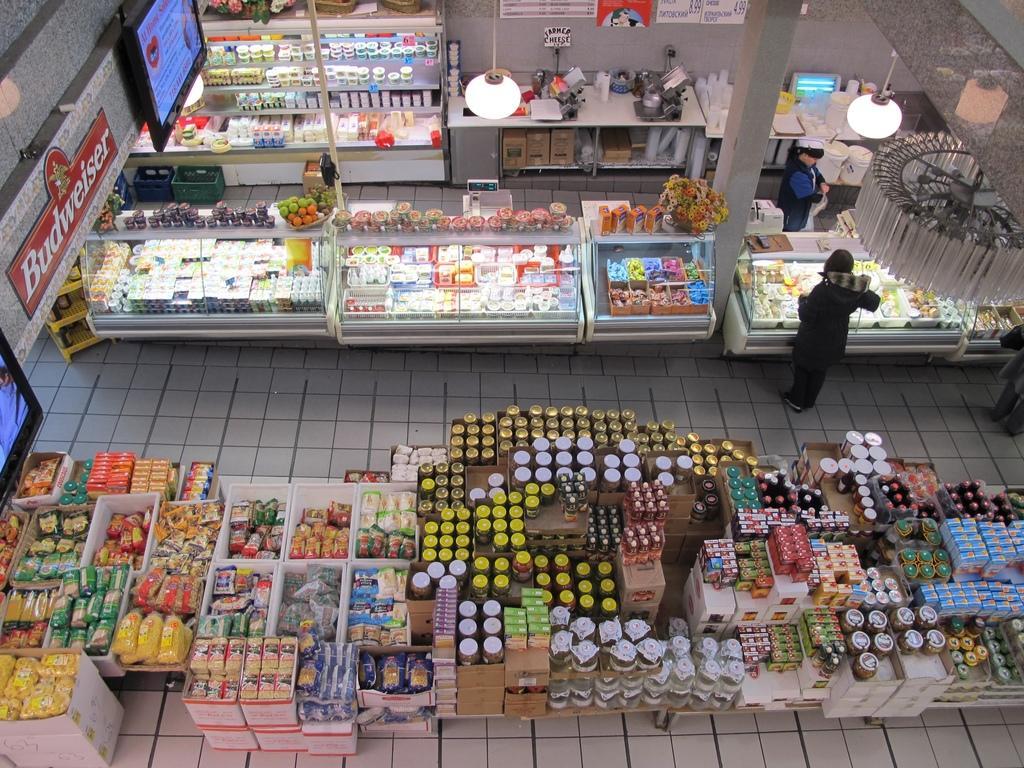Describe this image in one or two sentences. In the image we can see there are many people standing and wearing clothes. Here we can see the store, food items and lights. Here we can see the floor, screen, board and text on the board. 